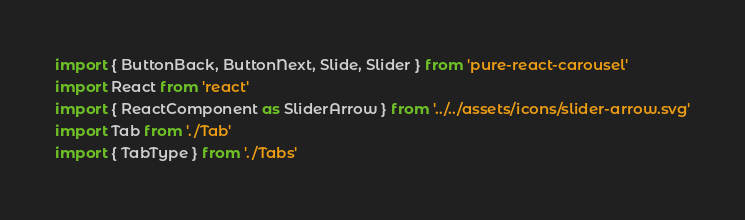<code> <loc_0><loc_0><loc_500><loc_500><_TypeScript_>import { ButtonBack, ButtonNext, Slide, Slider } from 'pure-react-carousel'
import React from 'react'
import { ReactComponent as SliderArrow } from '../../assets/icons/slider-arrow.svg'
import Tab from './Tab'
import { TabType } from './Tabs'
</code> 